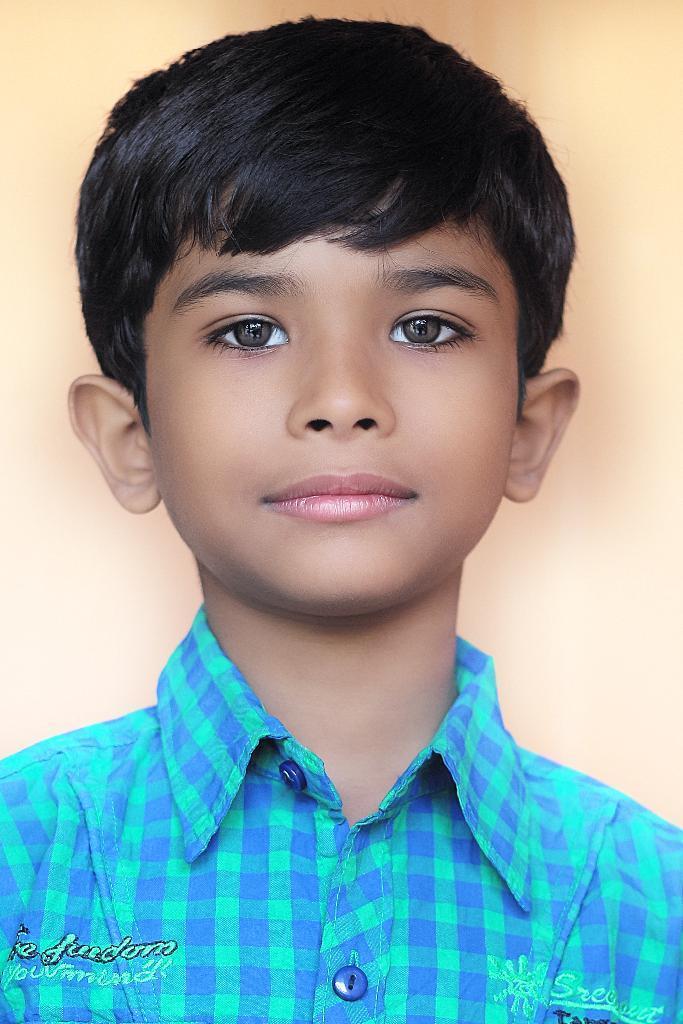Please provide a concise description of this image. In this image there is a photo of a person and there is some text on the shirt of a person. 